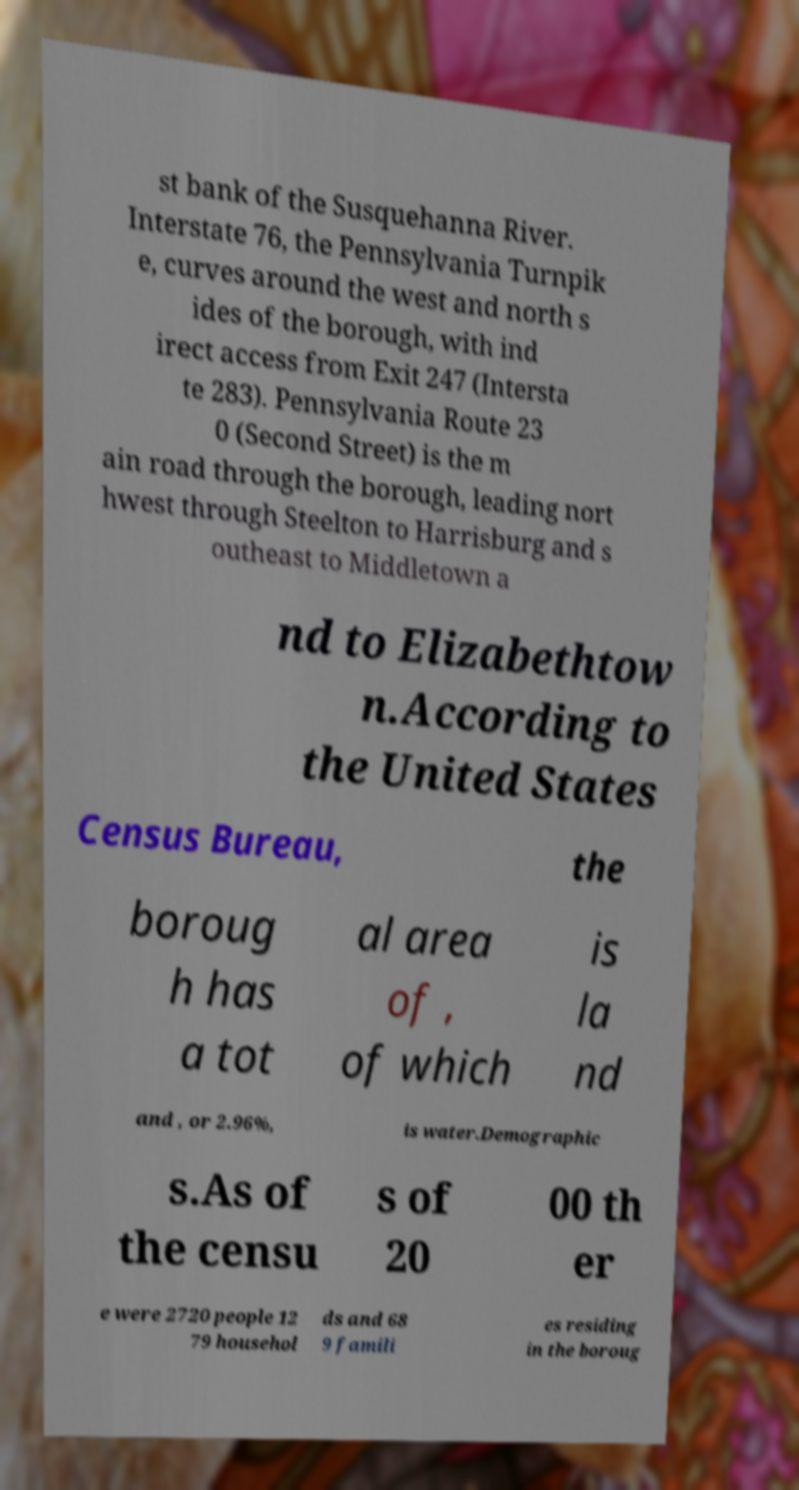I need the written content from this picture converted into text. Can you do that? st bank of the Susquehanna River. Interstate 76, the Pennsylvania Turnpik e, curves around the west and north s ides of the borough, with ind irect access from Exit 247 (Intersta te 283). Pennsylvania Route 23 0 (Second Street) is the m ain road through the borough, leading nort hwest through Steelton to Harrisburg and s outheast to Middletown a nd to Elizabethtow n.According to the United States Census Bureau, the boroug h has a tot al area of , of which is la nd and , or 2.96%, is water.Demographic s.As of the censu s of 20 00 th er e were 2720 people 12 79 househol ds and 68 9 famili es residing in the boroug 